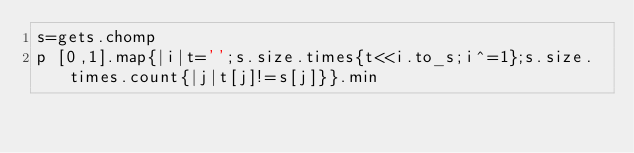<code> <loc_0><loc_0><loc_500><loc_500><_Ruby_>s=gets.chomp
p [0,1].map{|i|t='';s.size.times{t<<i.to_s;i^=1};s.size.times.count{|j|t[j]!=s[j]}}.min</code> 